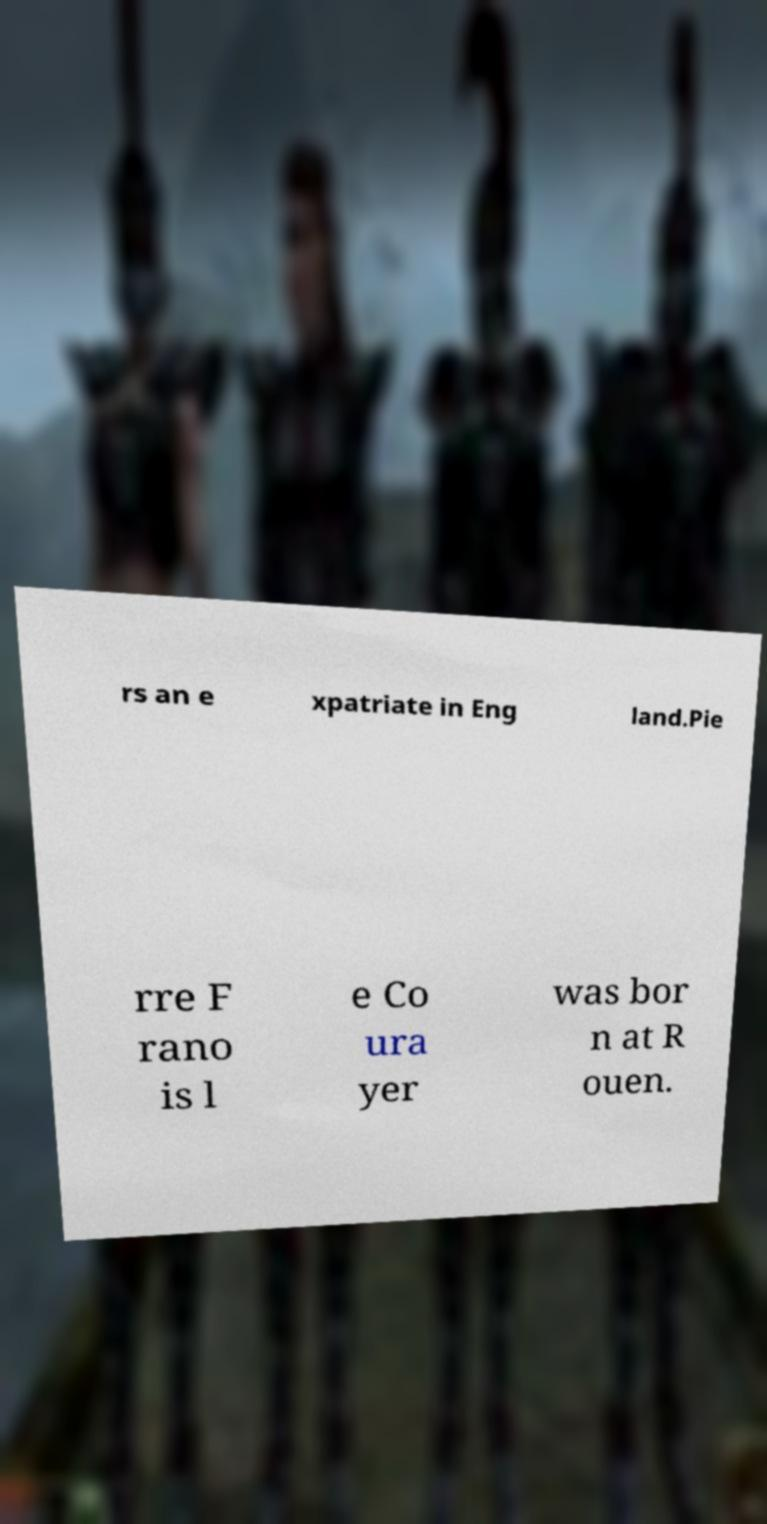Could you extract and type out the text from this image? rs an e xpatriate in Eng land.Pie rre F rano is l e Co ura yer was bor n at R ouen. 